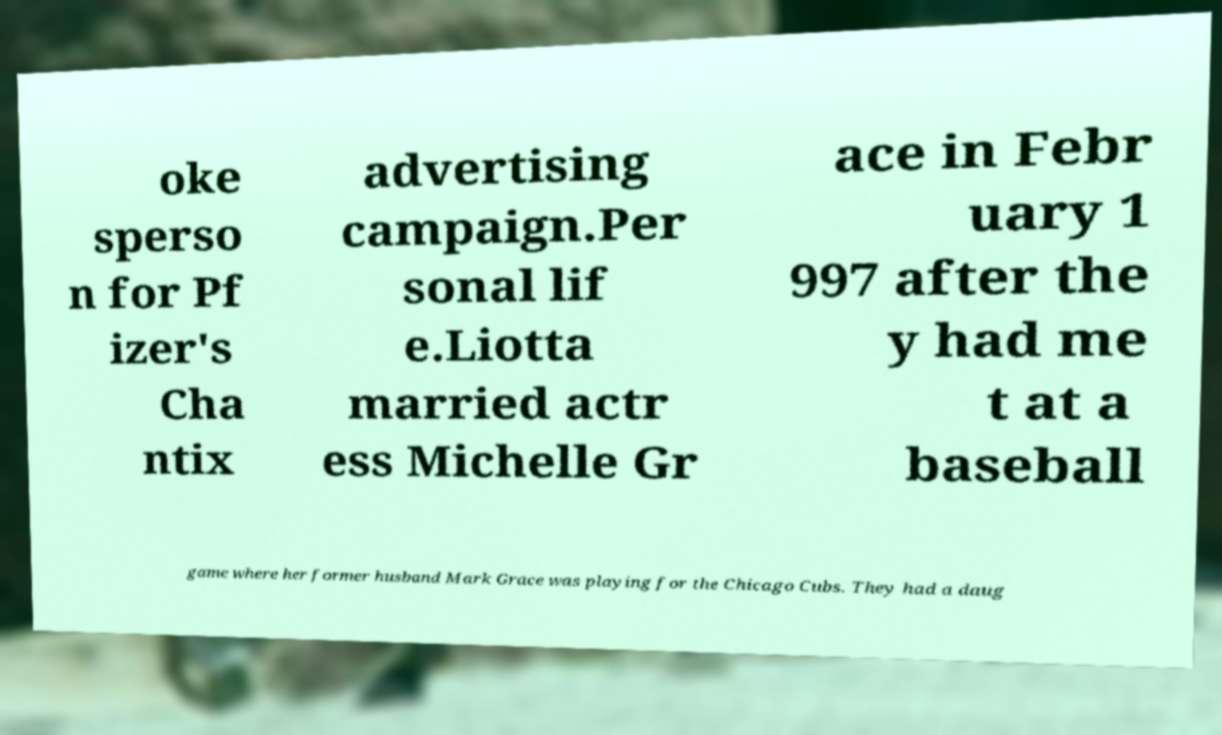I need the written content from this picture converted into text. Can you do that? oke sperso n for Pf izer's Cha ntix advertising campaign.Per sonal lif e.Liotta married actr ess Michelle Gr ace in Febr uary 1 997 after the y had me t at a baseball game where her former husband Mark Grace was playing for the Chicago Cubs. They had a daug 